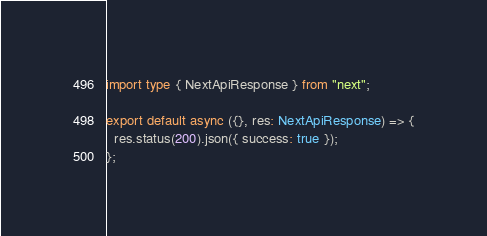Convert code to text. <code><loc_0><loc_0><loc_500><loc_500><_TypeScript_>import type { NextApiResponse } from "next";

export default async ({}, res: NextApiResponse) => {
  res.status(200).json({ success: true });
};
</code> 